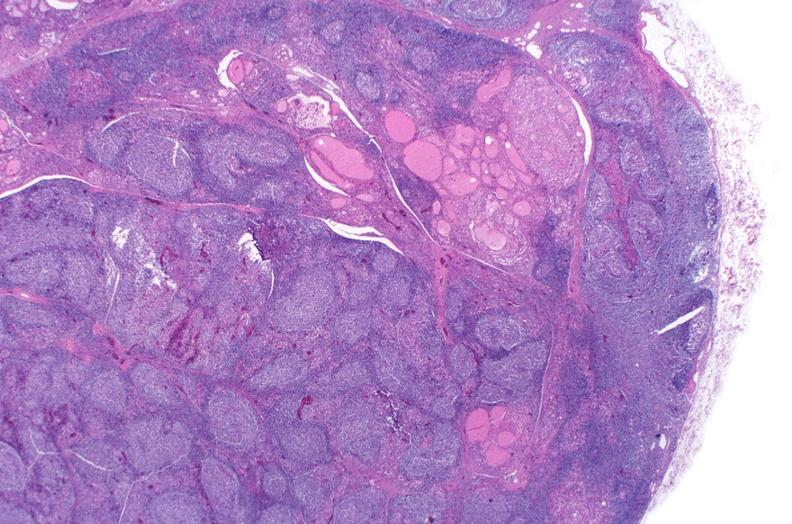s this image present?
Answer the question using a single word or phrase. No 